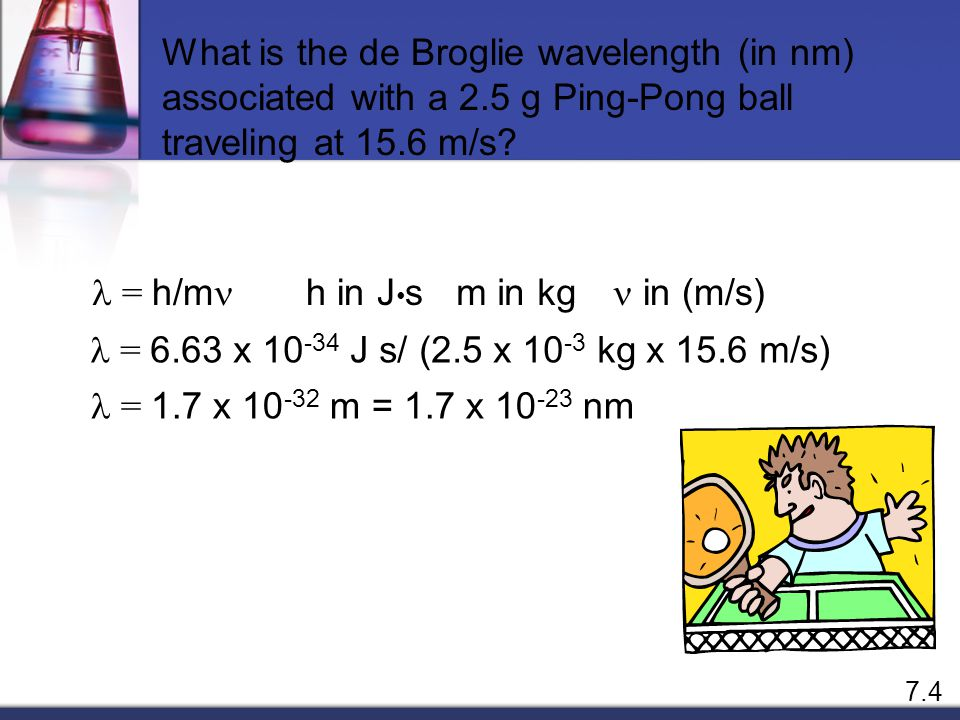Why does the boy look surprised while playing ping-pong? The boy's surprised expression could be illustrating the amazement or disbelief that one might feel upon learning that every object, including a seemingly innocuous ping-pong ball, has a wavelength according to the de Broglie hypothesis. This visual could be emphasizing the 'wonder' aspect of scientific discoveries, making the study of physics more intriguing and relatable. 